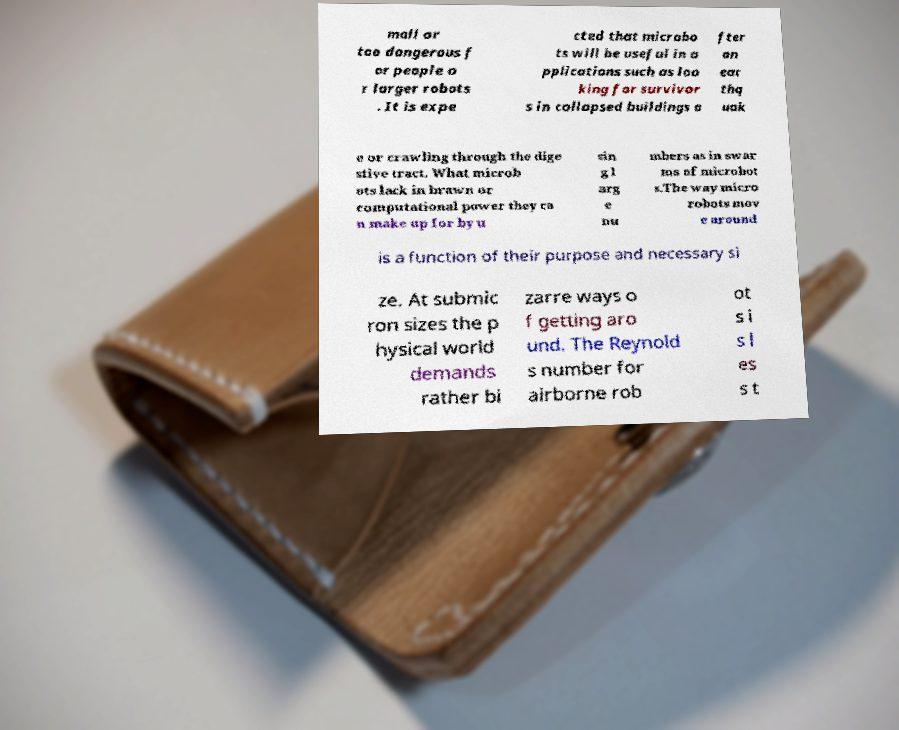Please identify and transcribe the text found in this image. mall or too dangerous f or people o r larger robots . It is expe cted that microbo ts will be useful in a pplications such as loo king for survivor s in collapsed buildings a fter an ear thq uak e or crawling through the dige stive tract. What microb ots lack in brawn or computational power they ca n make up for by u sin g l arg e nu mbers as in swar ms of microbot s.The way micro robots mov e around is a function of their purpose and necessary si ze. At submic ron sizes the p hysical world demands rather bi zarre ways o f getting aro und. The Reynold s number for airborne rob ot s i s l es s t 